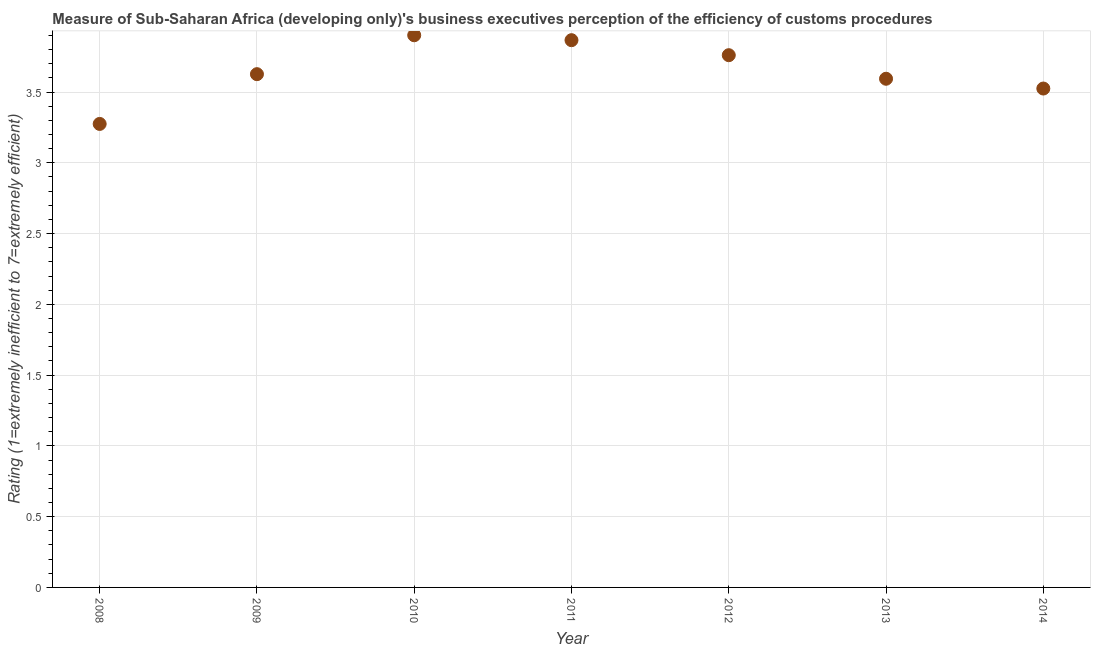What is the rating measuring burden of customs procedure in 2010?
Give a very brief answer. 3.9. Across all years, what is the maximum rating measuring burden of customs procedure?
Give a very brief answer. 3.9. Across all years, what is the minimum rating measuring burden of customs procedure?
Your answer should be compact. 3.27. In which year was the rating measuring burden of customs procedure maximum?
Offer a terse response. 2010. In which year was the rating measuring burden of customs procedure minimum?
Give a very brief answer. 2008. What is the sum of the rating measuring burden of customs procedure?
Your response must be concise. 25.55. What is the difference between the rating measuring burden of customs procedure in 2011 and 2013?
Your answer should be very brief. 0.27. What is the average rating measuring burden of customs procedure per year?
Provide a short and direct response. 3.65. What is the median rating measuring burden of customs procedure?
Offer a terse response. 3.63. In how many years, is the rating measuring burden of customs procedure greater than 2.2 ?
Make the answer very short. 7. Do a majority of the years between 2010 and 2014 (inclusive) have rating measuring burden of customs procedure greater than 1.4 ?
Make the answer very short. Yes. What is the ratio of the rating measuring burden of customs procedure in 2010 to that in 2012?
Your answer should be compact. 1.04. What is the difference between the highest and the second highest rating measuring burden of customs procedure?
Your response must be concise. 0.03. Is the sum of the rating measuring burden of customs procedure in 2010 and 2013 greater than the maximum rating measuring burden of customs procedure across all years?
Keep it short and to the point. Yes. What is the difference between the highest and the lowest rating measuring burden of customs procedure?
Your answer should be compact. 0.63. Does the rating measuring burden of customs procedure monotonically increase over the years?
Your answer should be very brief. No. Are the values on the major ticks of Y-axis written in scientific E-notation?
Provide a short and direct response. No. Does the graph contain any zero values?
Give a very brief answer. No. What is the title of the graph?
Provide a short and direct response. Measure of Sub-Saharan Africa (developing only)'s business executives perception of the efficiency of customs procedures. What is the label or title of the Y-axis?
Your response must be concise. Rating (1=extremely inefficient to 7=extremely efficient). What is the Rating (1=extremely inefficient to 7=extremely efficient) in 2008?
Ensure brevity in your answer.  3.27. What is the Rating (1=extremely inefficient to 7=extremely efficient) in 2009?
Your answer should be compact. 3.63. What is the Rating (1=extremely inefficient to 7=extremely efficient) in 2010?
Your answer should be very brief. 3.9. What is the Rating (1=extremely inefficient to 7=extremely efficient) in 2011?
Offer a very short reply. 3.87. What is the Rating (1=extremely inefficient to 7=extremely efficient) in 2012?
Ensure brevity in your answer.  3.76. What is the Rating (1=extremely inefficient to 7=extremely efficient) in 2013?
Give a very brief answer. 3.59. What is the Rating (1=extremely inefficient to 7=extremely efficient) in 2014?
Keep it short and to the point. 3.52. What is the difference between the Rating (1=extremely inefficient to 7=extremely efficient) in 2008 and 2009?
Offer a very short reply. -0.35. What is the difference between the Rating (1=extremely inefficient to 7=extremely efficient) in 2008 and 2010?
Offer a terse response. -0.63. What is the difference between the Rating (1=extremely inefficient to 7=extremely efficient) in 2008 and 2011?
Your response must be concise. -0.59. What is the difference between the Rating (1=extremely inefficient to 7=extremely efficient) in 2008 and 2012?
Provide a succinct answer. -0.49. What is the difference between the Rating (1=extremely inefficient to 7=extremely efficient) in 2008 and 2013?
Give a very brief answer. -0.32. What is the difference between the Rating (1=extremely inefficient to 7=extremely efficient) in 2008 and 2014?
Your answer should be compact. -0.25. What is the difference between the Rating (1=extremely inefficient to 7=extremely efficient) in 2009 and 2010?
Make the answer very short. -0.27. What is the difference between the Rating (1=extremely inefficient to 7=extremely efficient) in 2009 and 2011?
Give a very brief answer. -0.24. What is the difference between the Rating (1=extremely inefficient to 7=extremely efficient) in 2009 and 2012?
Provide a succinct answer. -0.13. What is the difference between the Rating (1=extremely inefficient to 7=extremely efficient) in 2009 and 2013?
Your answer should be very brief. 0.03. What is the difference between the Rating (1=extremely inefficient to 7=extremely efficient) in 2009 and 2014?
Offer a terse response. 0.1. What is the difference between the Rating (1=extremely inefficient to 7=extremely efficient) in 2010 and 2011?
Provide a short and direct response. 0.03. What is the difference between the Rating (1=extremely inefficient to 7=extremely efficient) in 2010 and 2012?
Ensure brevity in your answer.  0.14. What is the difference between the Rating (1=extremely inefficient to 7=extremely efficient) in 2010 and 2013?
Give a very brief answer. 0.31. What is the difference between the Rating (1=extremely inefficient to 7=extremely efficient) in 2010 and 2014?
Provide a succinct answer. 0.38. What is the difference between the Rating (1=extremely inefficient to 7=extremely efficient) in 2011 and 2012?
Your answer should be very brief. 0.11. What is the difference between the Rating (1=extremely inefficient to 7=extremely efficient) in 2011 and 2013?
Provide a short and direct response. 0.27. What is the difference between the Rating (1=extremely inefficient to 7=extremely efficient) in 2011 and 2014?
Your answer should be very brief. 0.34. What is the difference between the Rating (1=extremely inefficient to 7=extremely efficient) in 2012 and 2013?
Provide a short and direct response. 0.17. What is the difference between the Rating (1=extremely inefficient to 7=extremely efficient) in 2012 and 2014?
Provide a succinct answer. 0.24. What is the difference between the Rating (1=extremely inefficient to 7=extremely efficient) in 2013 and 2014?
Ensure brevity in your answer.  0.07. What is the ratio of the Rating (1=extremely inefficient to 7=extremely efficient) in 2008 to that in 2009?
Give a very brief answer. 0.9. What is the ratio of the Rating (1=extremely inefficient to 7=extremely efficient) in 2008 to that in 2010?
Give a very brief answer. 0.84. What is the ratio of the Rating (1=extremely inefficient to 7=extremely efficient) in 2008 to that in 2011?
Your response must be concise. 0.85. What is the ratio of the Rating (1=extremely inefficient to 7=extremely efficient) in 2008 to that in 2012?
Keep it short and to the point. 0.87. What is the ratio of the Rating (1=extremely inefficient to 7=extremely efficient) in 2008 to that in 2013?
Offer a terse response. 0.91. What is the ratio of the Rating (1=extremely inefficient to 7=extremely efficient) in 2008 to that in 2014?
Your response must be concise. 0.93. What is the ratio of the Rating (1=extremely inefficient to 7=extremely efficient) in 2009 to that in 2010?
Provide a short and direct response. 0.93. What is the ratio of the Rating (1=extremely inefficient to 7=extremely efficient) in 2009 to that in 2011?
Offer a very short reply. 0.94. What is the ratio of the Rating (1=extremely inefficient to 7=extremely efficient) in 2010 to that in 2011?
Your response must be concise. 1.01. What is the ratio of the Rating (1=extremely inefficient to 7=extremely efficient) in 2010 to that in 2013?
Give a very brief answer. 1.09. What is the ratio of the Rating (1=extremely inefficient to 7=extremely efficient) in 2010 to that in 2014?
Keep it short and to the point. 1.11. What is the ratio of the Rating (1=extremely inefficient to 7=extremely efficient) in 2011 to that in 2012?
Keep it short and to the point. 1.03. What is the ratio of the Rating (1=extremely inefficient to 7=extremely efficient) in 2011 to that in 2013?
Your answer should be very brief. 1.08. What is the ratio of the Rating (1=extremely inefficient to 7=extremely efficient) in 2011 to that in 2014?
Provide a short and direct response. 1.1. What is the ratio of the Rating (1=extremely inefficient to 7=extremely efficient) in 2012 to that in 2013?
Provide a short and direct response. 1.05. What is the ratio of the Rating (1=extremely inefficient to 7=extremely efficient) in 2012 to that in 2014?
Offer a very short reply. 1.07. 